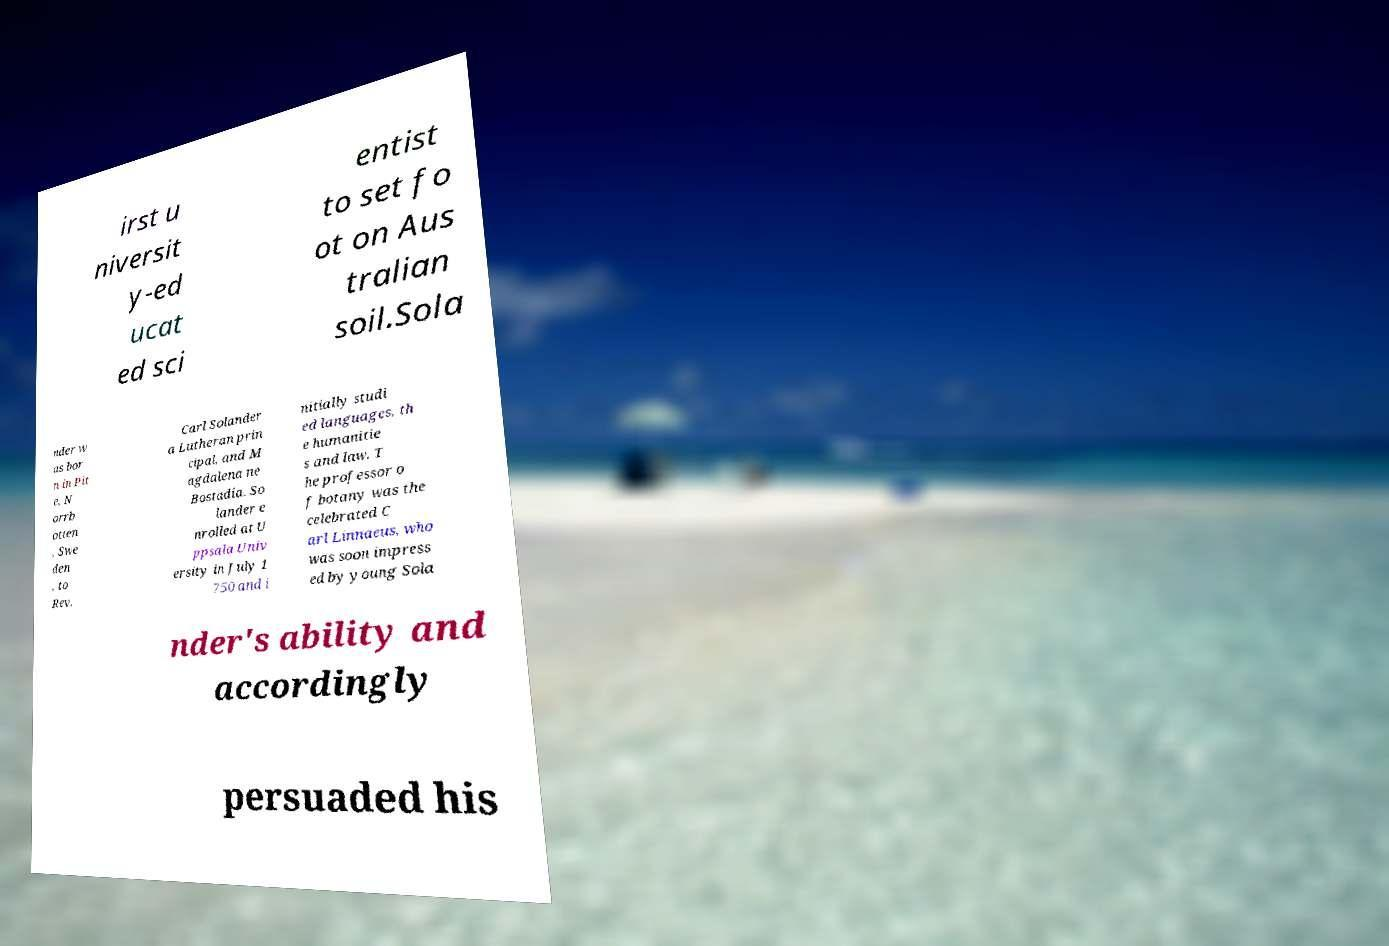Could you extract and type out the text from this image? irst u niversit y-ed ucat ed sci entist to set fo ot on Aus tralian soil.Sola nder w as bor n in Pit e, N orrb otten , Swe den , to Rev. Carl Solander a Lutheran prin cipal, and M agdalena ne Bostadia. So lander e nrolled at U ppsala Univ ersity in July 1 750 and i nitially studi ed languages, th e humanitie s and law. T he professor o f botany was the celebrated C arl Linnaeus, who was soon impress ed by young Sola nder's ability and accordingly persuaded his 